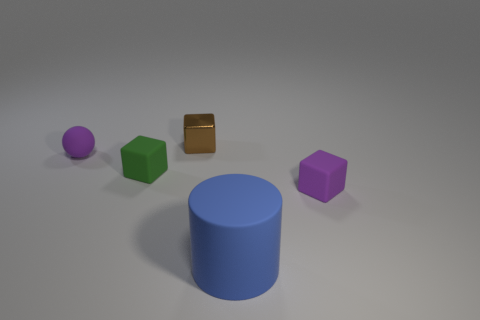How many other things are the same color as the sphere?
Your answer should be very brief. 1. What number of green matte things are the same size as the metallic cube?
Offer a very short reply. 1. There is a small object that is behind the small green object and to the left of the brown cube; what is its color?
Your answer should be very brief. Purple. Is the number of purple things less than the number of green rubber things?
Offer a very short reply. No. Does the ball have the same color as the small rubber thing that is right of the green cube?
Ensure brevity in your answer.  Yes. Are there an equal number of tiny purple objects behind the purple block and tiny spheres that are left of the blue cylinder?
Keep it short and to the point. Yes. What number of tiny green matte objects have the same shape as the metal object?
Provide a succinct answer. 1. Are there any brown matte cubes?
Keep it short and to the point. No. Is the material of the big blue object the same as the tiny purple object in front of the tiny purple sphere?
Your answer should be very brief. Yes. What is the material of the sphere that is the same size as the metal thing?
Provide a succinct answer. Rubber. 